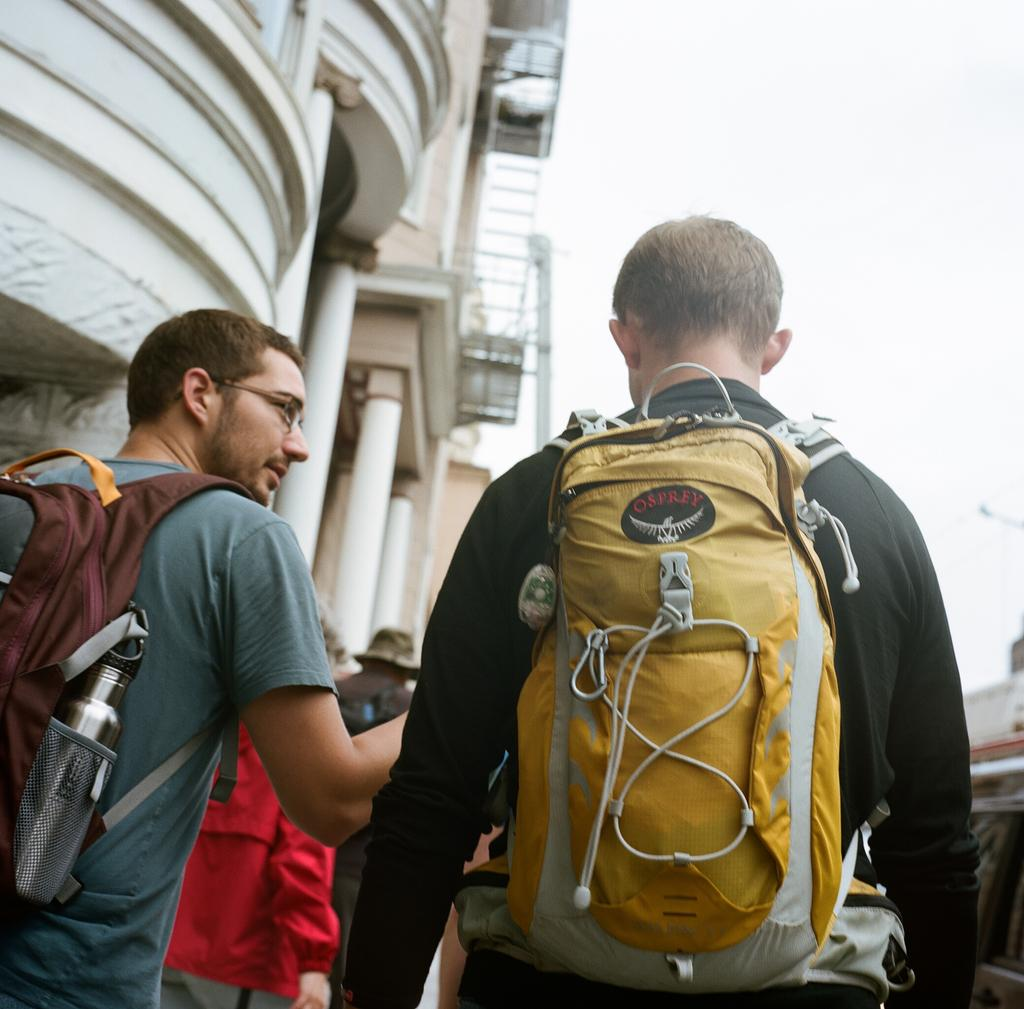How many men are in the image? There are two men in the image. What are the men wearing that is related to travel? The men are wearing luggage bags. Can you describe the contents of one of the bags? One of the men has a water bottle in his bag. What can be seen on the face of one of the men? One of the men is wearing glasses. What type of structure is visible in the background of the image? There is a building in the background of the image. What architectural features are present on the building? The building has pillars and a balcony. What type of hose is connected to the water bottle in the image? There is no hose connected to the water bottle in the image. How many masses are present in the image? There are no masses present in the image. 